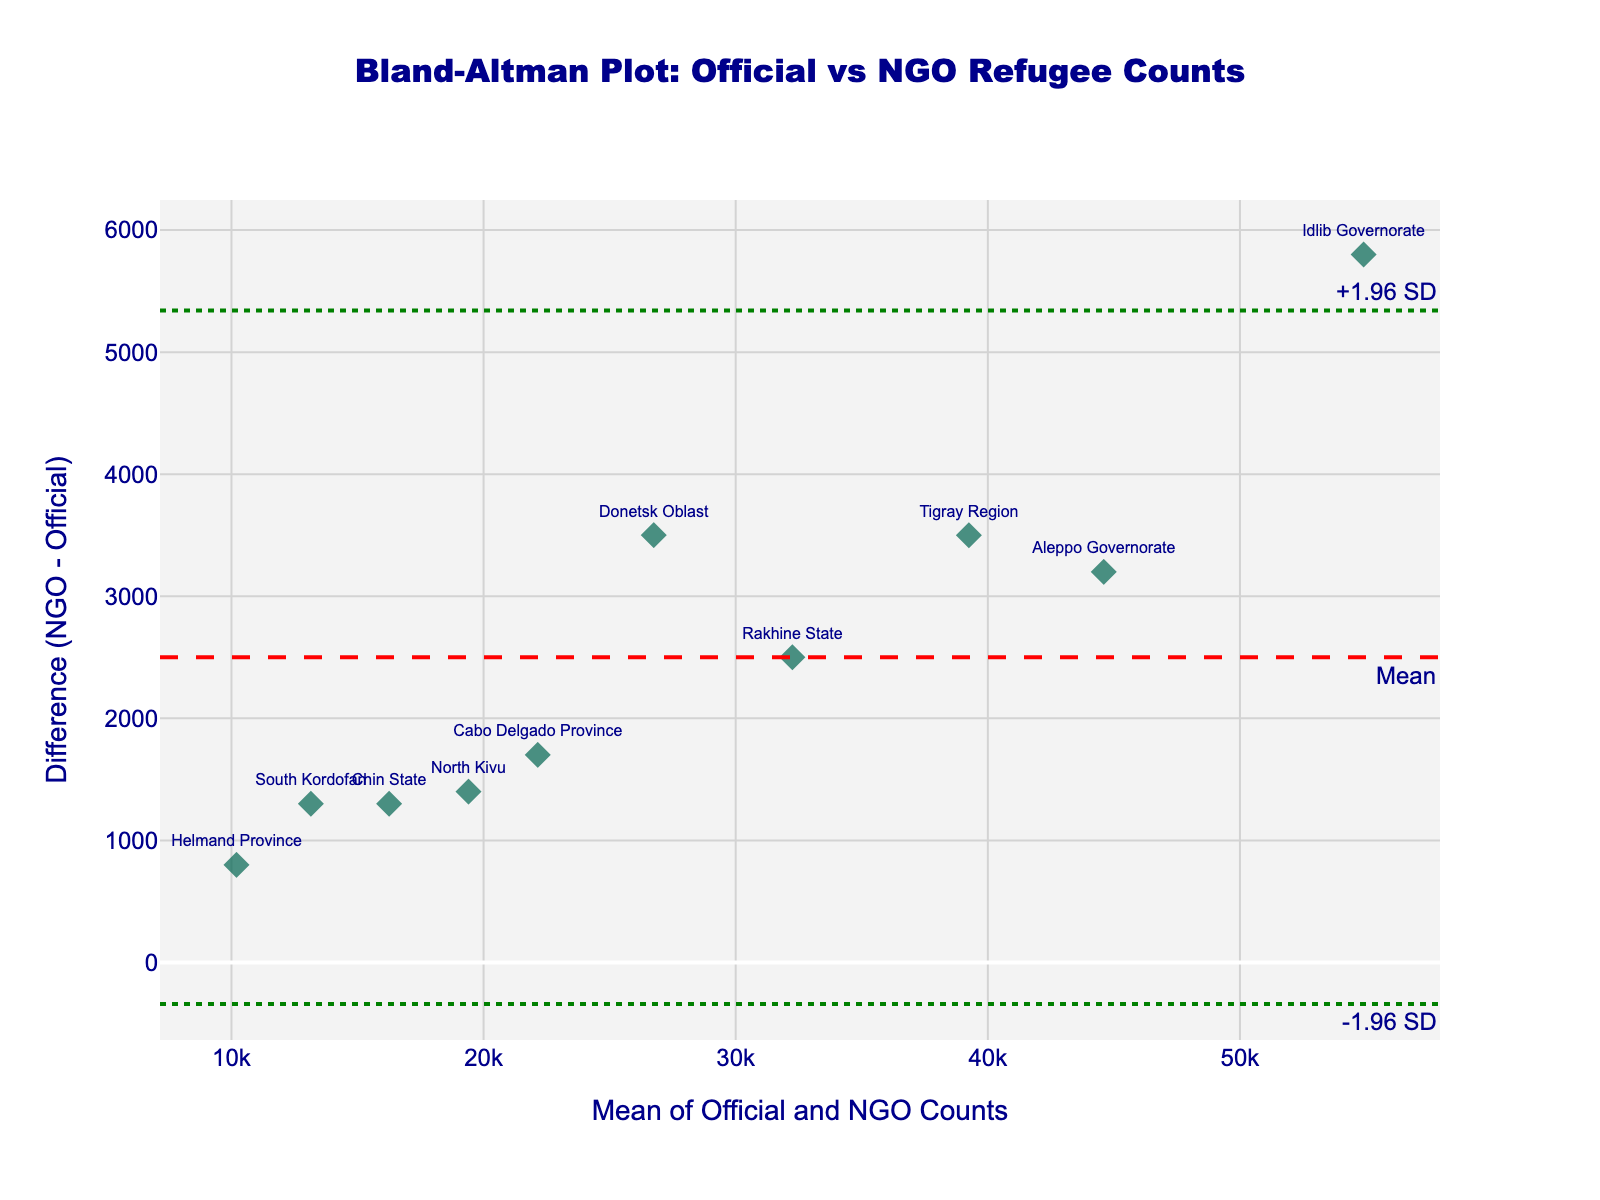How many regions are represented in the Bland-Altman plot? By counting the number of data points/markers in the scatter plot, each representing a different region, we realize there are 10 regions shown.
Answer: 10 What is the title of the Bland-Altman plot? The title of the plot is displayed at the top center of the figure. It reads "Bland-Altman Plot: Official vs NGO Refugee Counts".
Answer: Bland-Altman Plot: Official vs NGO Refugee Counts What do the dashed and dotted horizontal lines on the plot represent? The horizontal dashed line represents the mean difference between NGO and official counts, whereas the dotted lines represent the upper and lower limits of agreement at ±1.96 standard deviations from the mean difference.
Answer: Mean difference and limits of agreement In which region is the difference between NGO and official refugee counts the largest? By identifying the data point that is farthest from the dashed horizontal mean line (either above or below), we see Idlib Governorate has the largest difference.
Answer: Idlib Governorate What is the approximate mean count for the region shown in the plot with the text "Rakhine State"? Find "Rakhine State" on the plot and look horizontally to match with the mean value on the x-axis. The mean count is approximately halfway between 31,000 (official) and 33,500 (NGO), which it can be 32,250.
Answer: 32,250 How do the displacements reported by NGOs compare to the official counts on average? The position of most of the data points relative to the dashed line (mean difference) indicates if NGOs typically report higher or lower. Since most points are above the dashed line, it means NGO counts tend to be higher.
Answer: NGOs report higher counts Is there any region where the NGO and official refugee counts are nearly equal? Look for points close to the dashed mean difference line where the difference is near zero. No points are exactly on the line, but "Helmand Province" has the smallest difference, indicating near equality.
Answer: Helmand Province Which region has the smallest displacement figures reported? By finding the point with the smallest x-value (mean of counts) among the plotted points, "Helmand Province" has the lowest displacement figures.
Answer: Helmand Province 